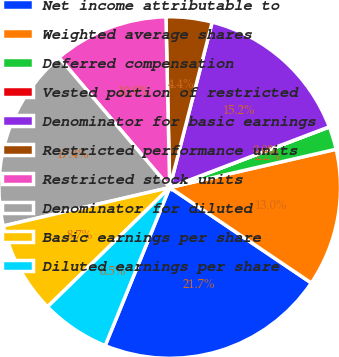<chart> <loc_0><loc_0><loc_500><loc_500><pie_chart><fcel>Net income attributable to<fcel>Weighted average shares<fcel>Deferred compensation<fcel>Vested portion of restricted<fcel>Denominator for basic earnings<fcel>Restricted performance units<fcel>Restricted stock units<fcel>Denominator for diluted<fcel>Basic earnings per share<fcel>Diluted earnings per share<nl><fcel>21.73%<fcel>13.04%<fcel>2.18%<fcel>0.01%<fcel>15.21%<fcel>4.35%<fcel>10.87%<fcel>17.39%<fcel>8.7%<fcel>6.52%<nl></chart> 